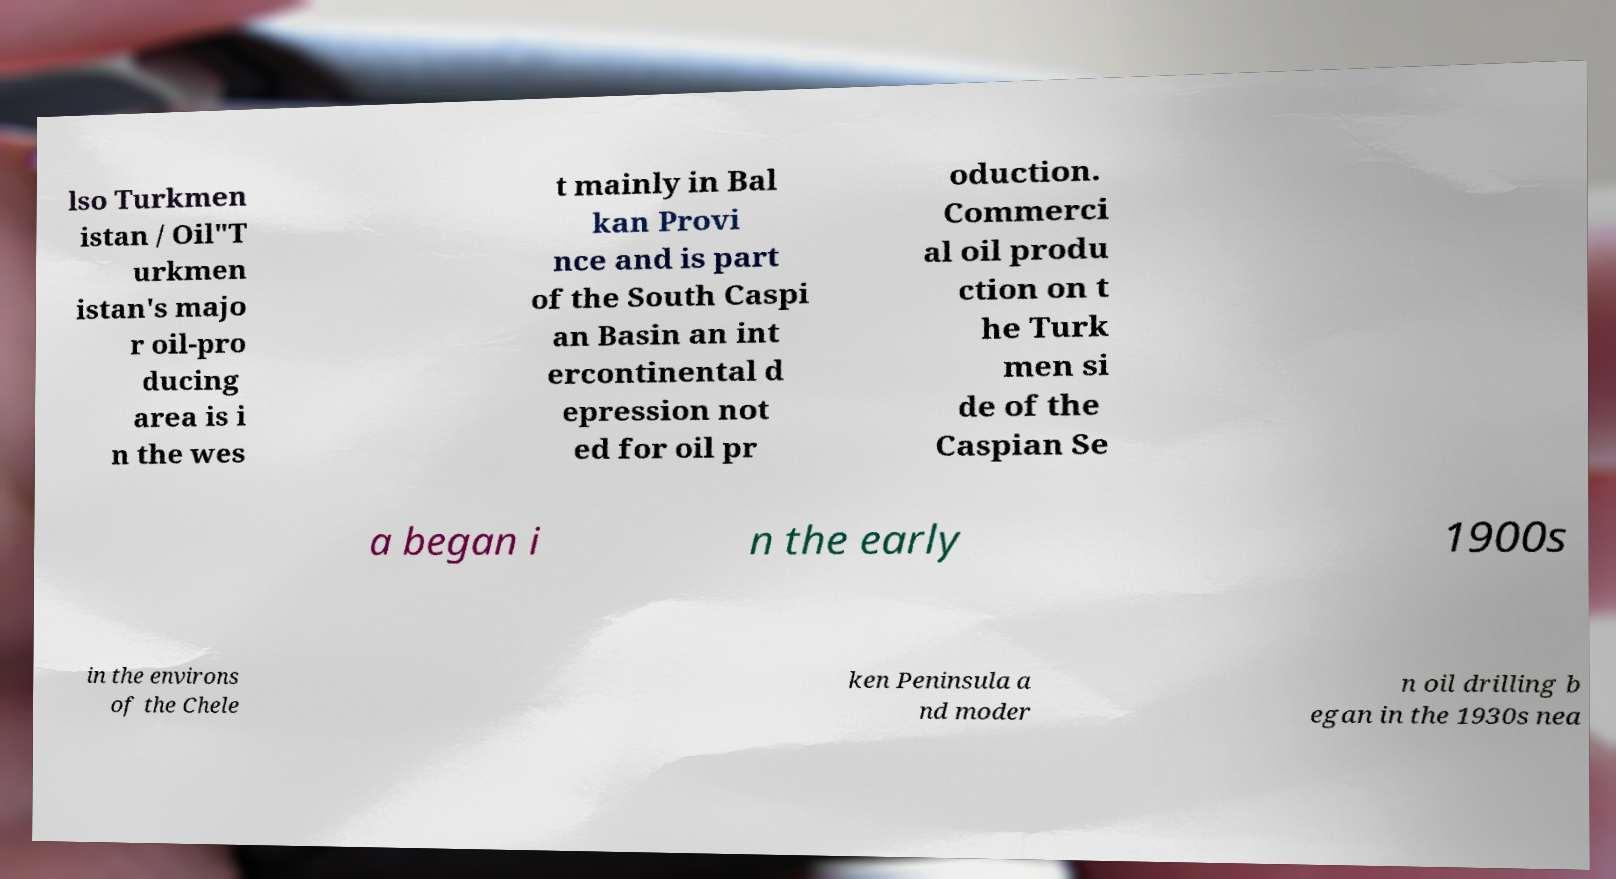Can you accurately transcribe the text from the provided image for me? lso Turkmen istan / Oil"T urkmen istan's majo r oil-pro ducing area is i n the wes t mainly in Bal kan Provi nce and is part of the South Caspi an Basin an int ercontinental d epression not ed for oil pr oduction. Commerci al oil produ ction on t he Turk men si de of the Caspian Se a began i n the early 1900s in the environs of the Chele ken Peninsula a nd moder n oil drilling b egan in the 1930s nea 